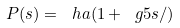Convert formula to latex. <formula><loc_0><loc_0><loc_500><loc_500>P ( s ) = \ h a ( 1 + \ g 5 s { / } )</formula> 